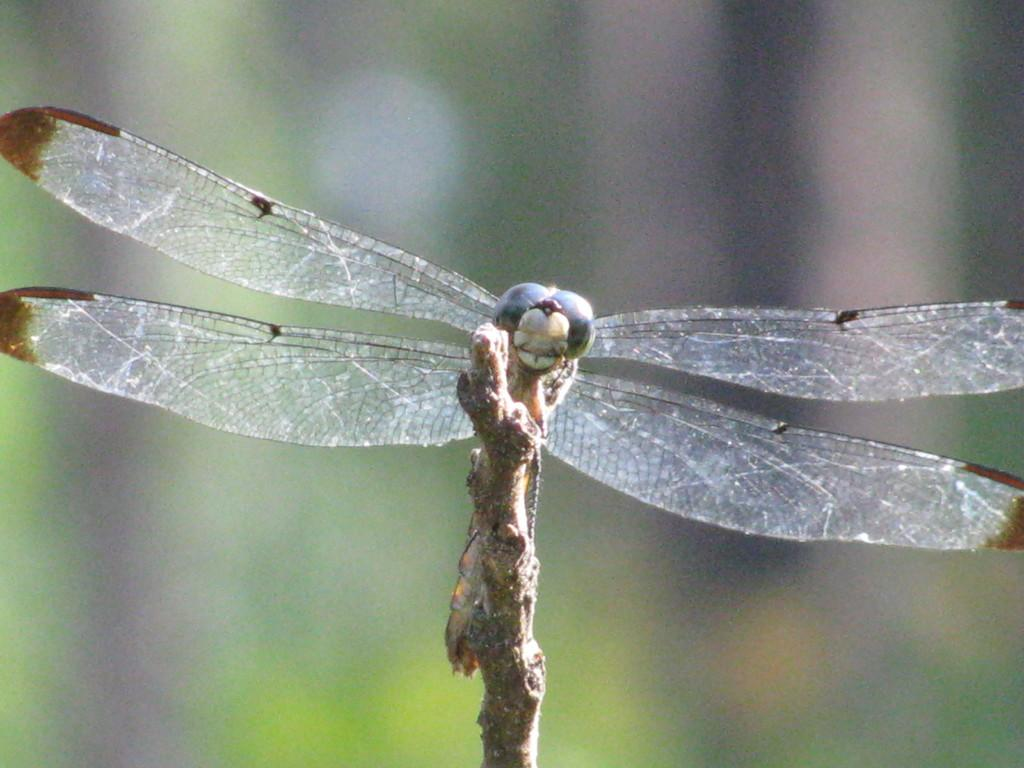What is the main subject in the foreground of the image? There is a dragonfly in the foreground of the image. What is the dragonfly resting on? The dragonfly is on a stick. Can you describe the background of the image? The background of the image is blurred. What type of hammer is being used to fix the system in the image? There is no hammer or system present in the image; it features a dragonfly on a stick with a blurred background. 